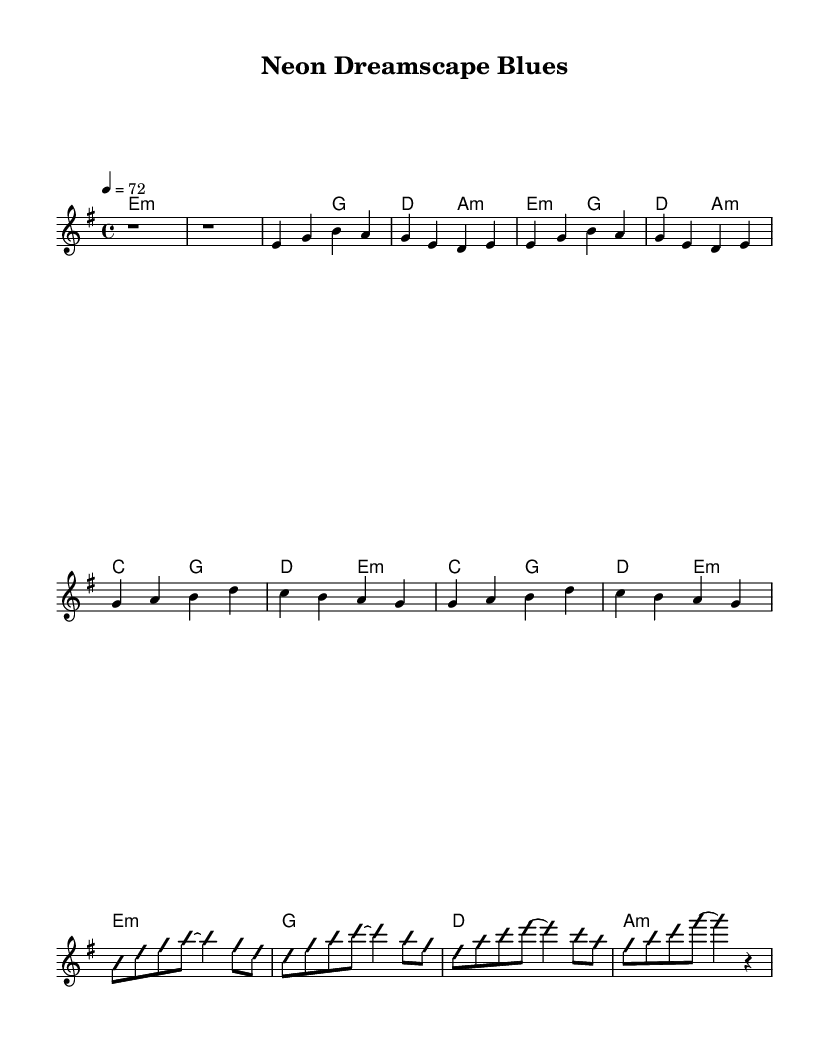What is the key signature of this music? The key signature is E minor, indicated by the presence of one sharp (F#) in the music staff. The presence of the key signature allows us to determine the tonal center of the piece, which is E minor.
Answer: E minor What is the time signature of this music? The time signature is 4/4, shown at the beginning of the score. This means there are four beats in each measure, and the quarter note gets one beat. It's a common time signature for many musical genres, including blues.
Answer: 4/4 What is the tempo marking for this piece? The tempo marking is 72 beats per minute, indicated at the beginning of the score. This gives the performer a specific speed for performing the piece.
Answer: 72 How many measures are in the verse section? The verse section consists of 4 measures. Each phrase of both the lyrics and chord changes offers 2 measures, summing up to 4 measures total.
Answer: 4 Which chord is played in the intro? The chord played in the intro is E minor, as written in the chord names section at the beginning of the music. This sets the foundation for the rest of the piece.
Answer: E minor What section follows the chorus? The section that follows the chorus is the guitar solo, determined by the lack of a vocal line and the presence of improvisation notations in the music. This showcases the experimental nature typical of electric blues.
Answer: Guitar Solo What style of music does this sheet represent? This sheet represents psychedelic-influenced electric blues, which is typical for its experimental guitar effects and surreal storytelling elements. The use of improvisation is also key to the style.
Answer: Electric Blues 